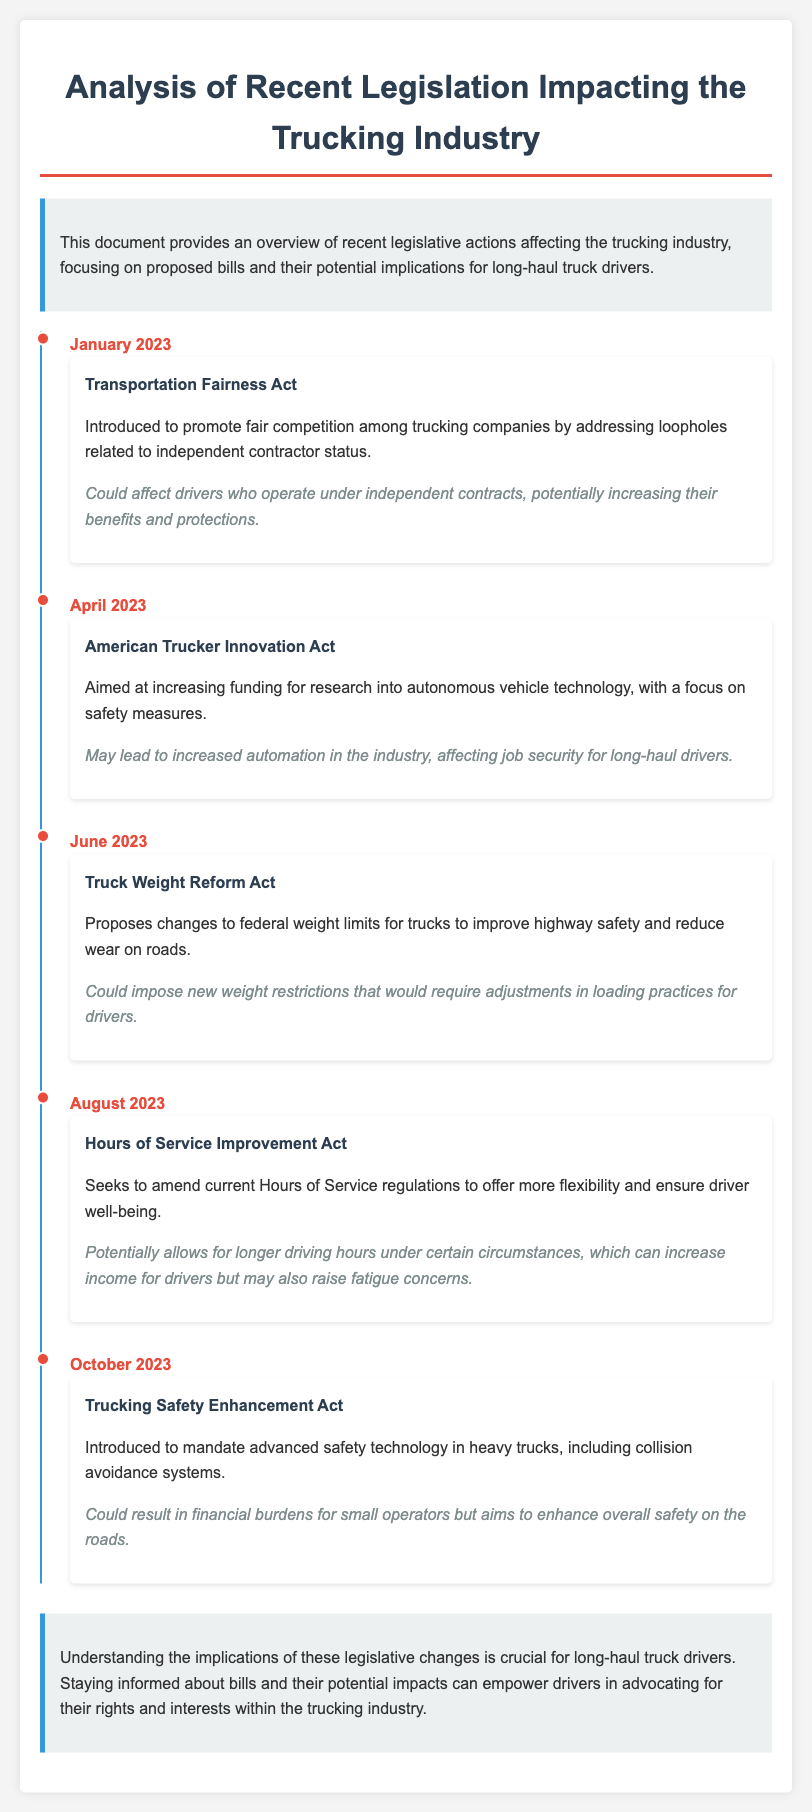What is the name of the bill introduced in January 2023? The document states that the bill introduced in January 2023 is the Transportation Fairness Act.
Answer: Transportation Fairness Act What is a potential effect of the American Trucker Innovation Act? The document mentions that a potential effect could be increased automation in the industry, affecting job security for long-haul drivers.
Answer: Increased automation What changes does the Truck Weight Reform Act propose? According to the document, the Truck Weight Reform Act proposes changes to federal weight limits for trucks.
Answer: Changes to federal weight limits When was the Hours of Service Improvement Act introduced? The document specifies that the Hours of Service Improvement Act was introduced in August 2023.
Answer: August 2023 What is a potential concern related to the Hours of Service Improvement Act? The document highlights that a concern could be raised about increased fatigue among drivers due to longer driving hours.
Answer: Increased fatigue What type of technology is mandated by the Trucking Safety Enhancement Act? It is noted in the document that the Trucking Safety Enhancement Act mandates advanced safety technology, including collision avoidance systems.
Answer: Advanced safety technology How many bills are mentioned in the legislative timeline? The document lists five bills in the timeline impacting the trucking industry.
Answer: Five What is the main purpose of the Transportation Fairness Act? The document states that the purpose is to promote fair competition among trucking companies.
Answer: Promote fair competition What is a potential financial effect of the Trucking Safety Enhancement Act? The document indicates that it could result in financial burdens for small operators.
Answer: Financial burdens for small operators 